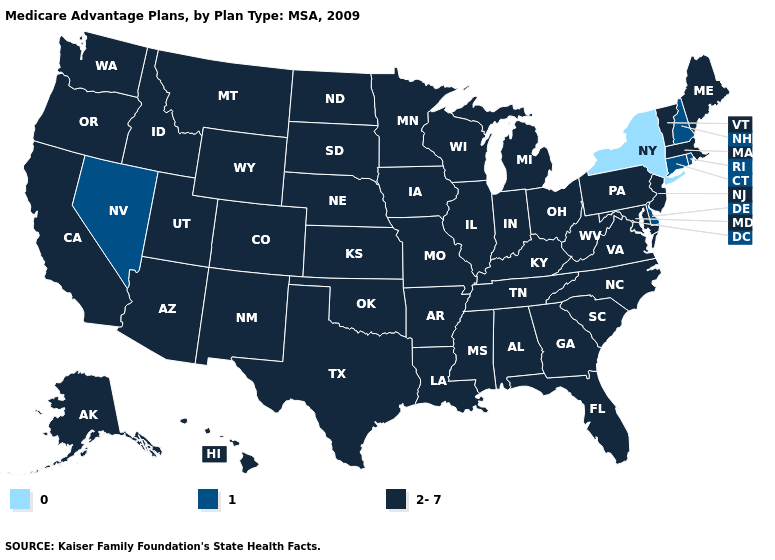Name the states that have a value in the range 1?
Give a very brief answer. Connecticut, Delaware, New Hampshire, Nevada, Rhode Island. Among the states that border Pennsylvania , does Maryland have the highest value?
Give a very brief answer. Yes. Which states have the lowest value in the USA?
Write a very short answer. New York. Name the states that have a value in the range 0?
Be succinct. New York. What is the value of Tennessee?
Be succinct. 2-7. Does Rhode Island have the highest value in the Northeast?
Give a very brief answer. No. Does Delaware have the highest value in the South?
Be succinct. No. Does Kentucky have the lowest value in the South?
Give a very brief answer. No. What is the highest value in states that border Idaho?
Answer briefly. 2-7. What is the value of Illinois?
Concise answer only. 2-7. What is the value of Connecticut?
Give a very brief answer. 1. What is the highest value in states that border Indiana?
Quick response, please. 2-7. Does the first symbol in the legend represent the smallest category?
Keep it brief. Yes. Among the states that border Vermont , which have the highest value?
Write a very short answer. Massachusetts. 